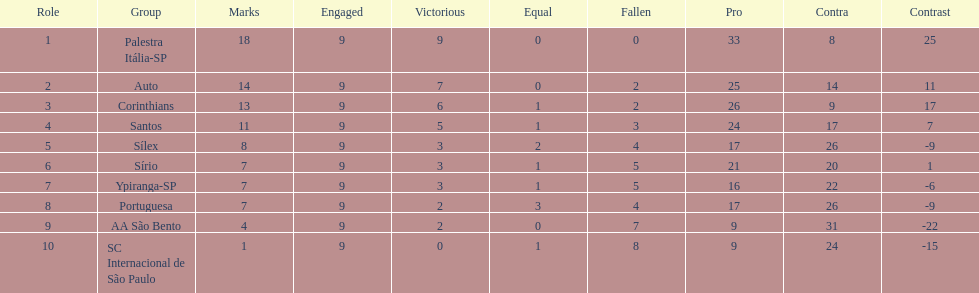Which brazilian team took the top spot in the 1926 brazilian football cup? Palestra Itália-SP. I'm looking to parse the entire table for insights. Could you assist me with that? {'header': ['Role', 'Group', 'Marks', 'Engaged', 'Victorious', 'Equal', 'Fallen', 'Pro', 'Contra', 'Contrast'], 'rows': [['1', 'Palestra Itália-SP', '18', '9', '9', '0', '0', '33', '8', '25'], ['2', 'Auto', '14', '9', '7', '0', '2', '25', '14', '11'], ['3', 'Corinthians', '13', '9', '6', '1', '2', '26', '9', '17'], ['4', 'Santos', '11', '9', '5', '1', '3', '24', '17', '7'], ['5', 'Sílex', '8', '9', '3', '2', '4', '17', '26', '-9'], ['6', 'Sírio', '7', '9', '3', '1', '5', '21', '20', '1'], ['7', 'Ypiranga-SP', '7', '9', '3', '1', '5', '16', '22', '-6'], ['8', 'Portuguesa', '7', '9', '2', '3', '4', '17', '26', '-9'], ['9', 'AA São Bento', '4', '9', '2', '0', '7', '9', '31', '-22'], ['10', 'SC Internacional de São Paulo', '1', '9', '0', '1', '8', '9', '24', '-15']]} 